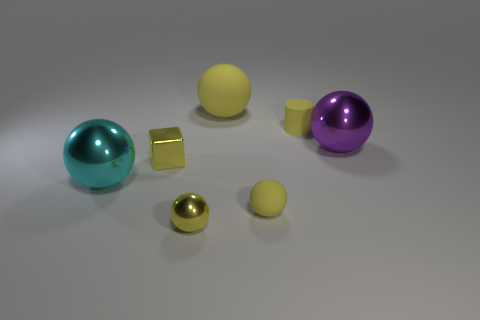What is the color of the large rubber thing that is the same shape as the cyan metallic thing?
Ensure brevity in your answer.  Yellow. Is the number of small spheres in front of the small yellow metallic ball less than the number of large purple metallic spheres?
Provide a succinct answer. Yes. Is there any other thing that has the same size as the cylinder?
Your response must be concise. Yes. There is a object right of the tiny object that is behind the big purple shiny thing; what size is it?
Provide a succinct answer. Large. Are there any other things that are the same shape as the purple metallic thing?
Offer a terse response. Yes. Are there fewer cyan spheres than red matte cylinders?
Offer a terse response. No. There is a object that is both in front of the cyan ball and on the right side of the large matte ball; what is its material?
Offer a terse response. Rubber. There is a matte ball behind the small yellow metallic block; is there a small metallic block on the right side of it?
Your answer should be very brief. No. How many objects are either blocks or big metal objects?
Provide a short and direct response. 3. The small yellow thing that is both behind the large cyan ball and on the right side of the tiny yellow metal block has what shape?
Provide a short and direct response. Cylinder. 